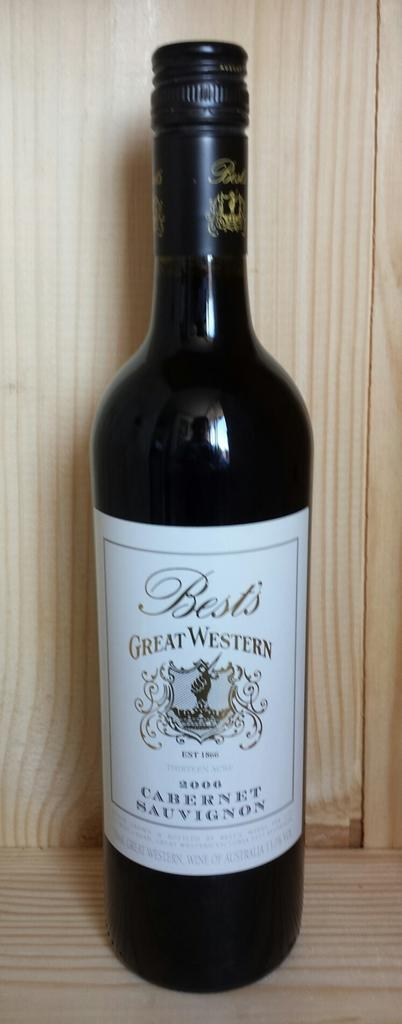<image>
Describe the image concisely. The black bottle had the words Great Western written on the logo. 